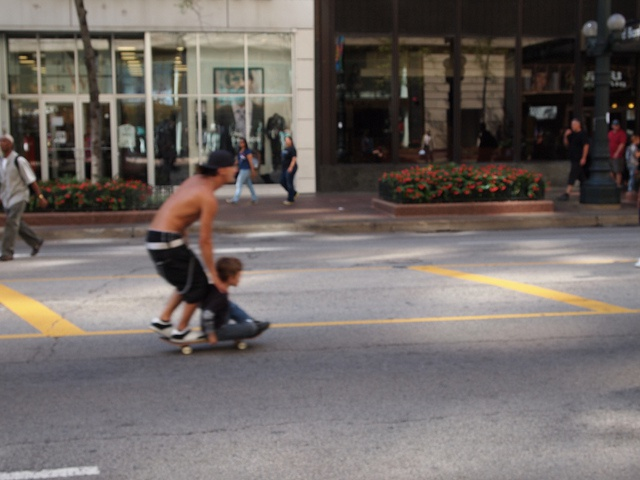Describe the objects in this image and their specific colors. I can see people in darkgray, black, brown, and maroon tones, people in darkgray, gray, and black tones, people in darkgray, black, gray, and maroon tones, people in darkgray, black, maroon, and brown tones, and people in darkgray, gray, black, and maroon tones in this image. 